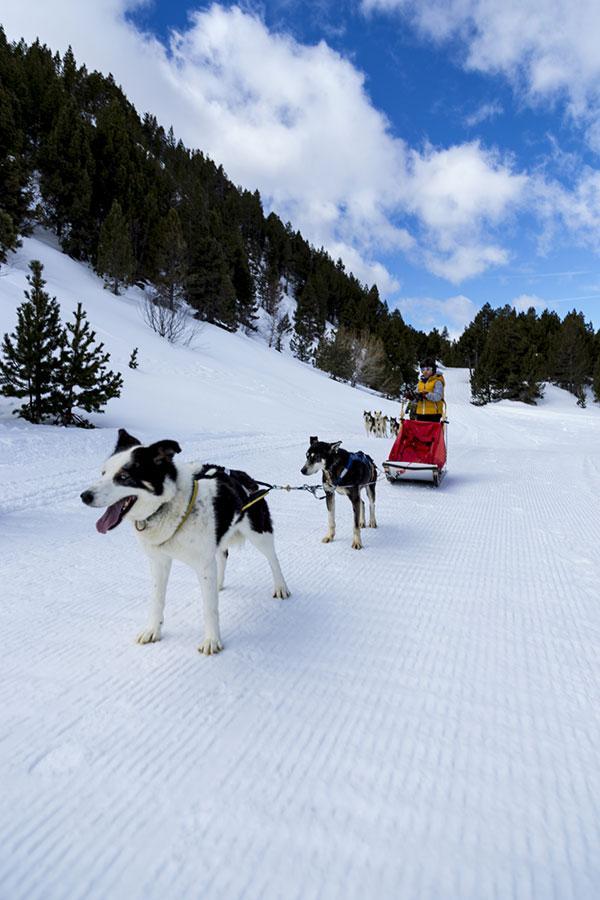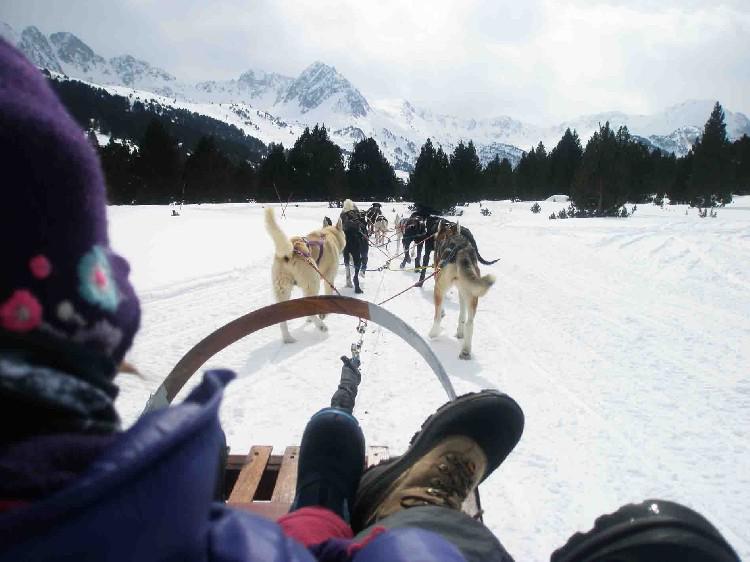The first image is the image on the left, the second image is the image on the right. Evaluate the accuracy of this statement regarding the images: "An image shows a sled pulled by two dogs, heading downward and leftward.". Is it true? Answer yes or no. Yes. The first image is the image on the left, the second image is the image on the right. For the images shown, is this caption "The image on the left has a person using a red sled." true? Answer yes or no. Yes. 